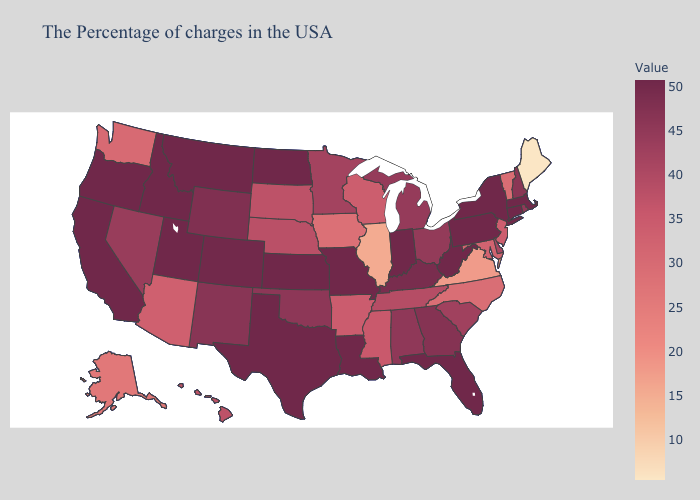Among the states that border Idaho , which have the lowest value?
Keep it brief. Washington. Does Colorado have the lowest value in the USA?
Quick response, please. No. Does North Dakota have the highest value in the MidWest?
Short answer required. Yes. Among the states that border North Carolina , does Virginia have the lowest value?
Write a very short answer. Yes. Which states have the lowest value in the MidWest?
Short answer required. Illinois. Which states hav the highest value in the South?
Answer briefly. West Virginia, Florida, Louisiana, Texas. 